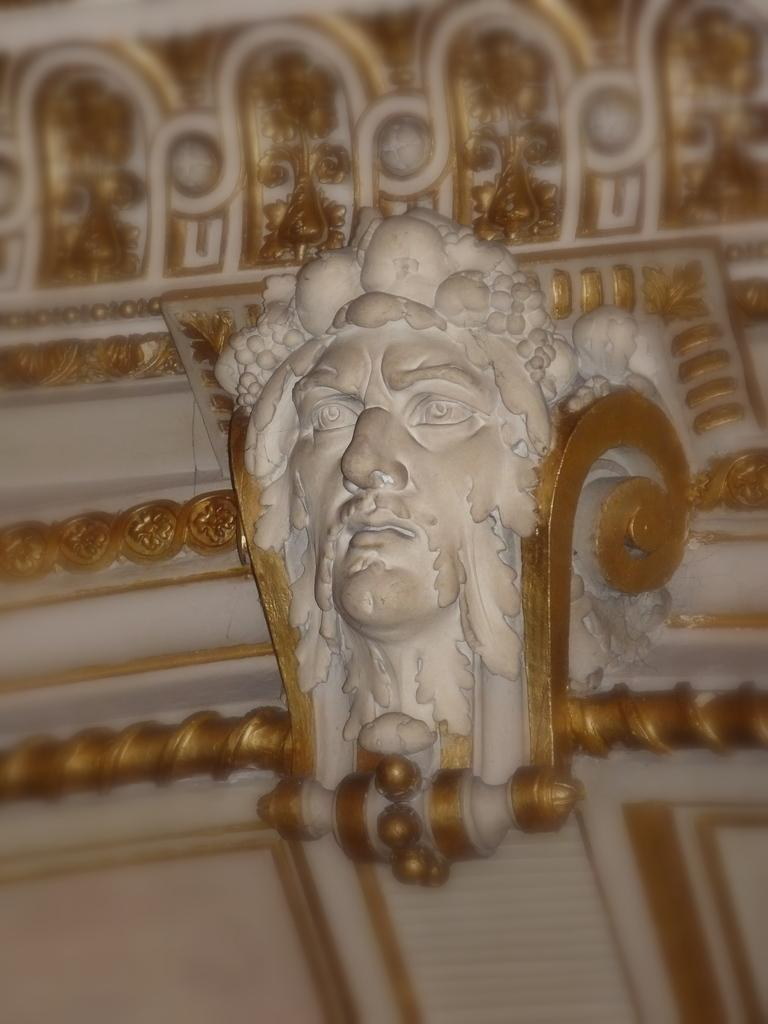What is the main subject of the image? There is a sculpture in the image. Can you describe the background of the image? The background of the image is blurred. How many cubs can be seen playing with the duck in the image? There is no mention of cubs or a duck in the image; it features a sculpture with a blurred background. 